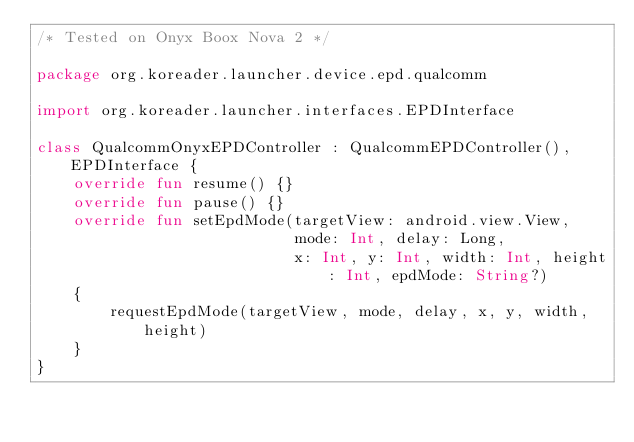<code> <loc_0><loc_0><loc_500><loc_500><_Kotlin_>/* Tested on Onyx Boox Nova 2 */

package org.koreader.launcher.device.epd.qualcomm

import org.koreader.launcher.interfaces.EPDInterface

class QualcommOnyxEPDController : QualcommEPDController(), EPDInterface {
    override fun resume() {}
    override fun pause() {}
    override fun setEpdMode(targetView: android.view.View,
                            mode: Int, delay: Long,
                            x: Int, y: Int, width: Int, height: Int, epdMode: String?)
    {
        requestEpdMode(targetView, mode, delay, x, y, width, height)
    }
}
</code> 